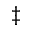<formula> <loc_0><loc_0><loc_500><loc_500>\ddagger</formula> 